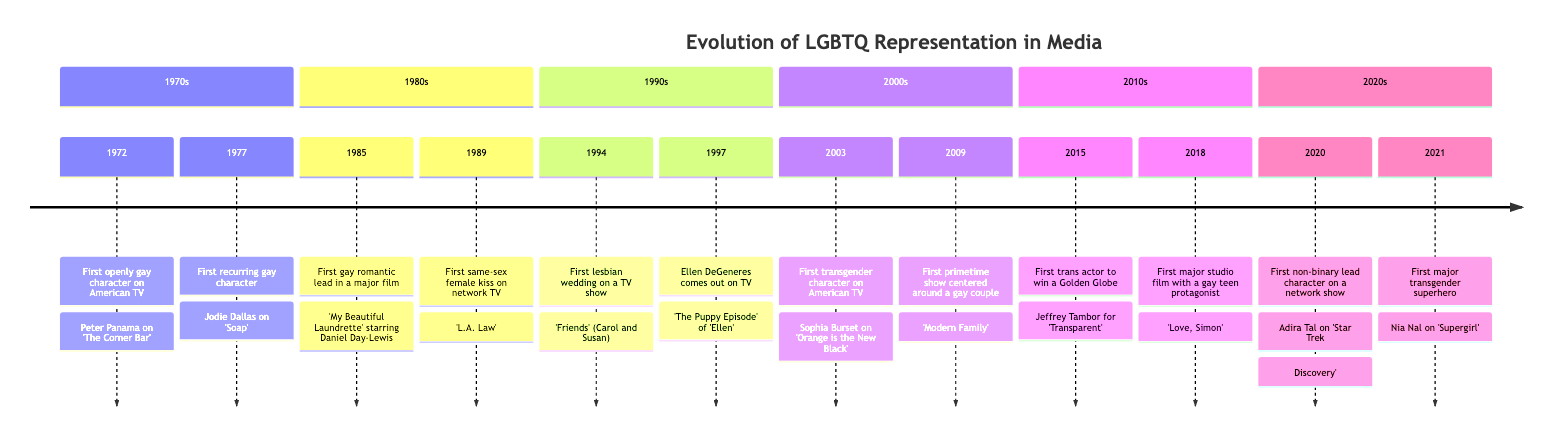What was the first openly gay character on American TV? The first openly gay character on American TV, as indicated in the diagram, is Peter Panama from 'The Corner Bar' in 1972.
Answer: Peter Panama What year did Ellen DeGeneres come out on TV? According to the timeline, Ellen DeGeneres came out on TV in 1997 during 'The Puppy Episode' of 'Ellen'.
Answer: 1997 How many key milestones are listed for the 2000s? The timeline shows two key milestones for the 2000s: the first transgender character in 2003 and the first primetime show centered around a gay couple in 2009, totaling two milestones.
Answer: 2 Which decade saw the first same-sex female kiss on network TV? The first same-sex female kiss on network TV occurred in 1989 on 'L.A. Law', so this milestone belongs to the 1980s.
Answer: 1980s What is significant about the first major studio film in 2018? The significant aspect of the film 'Love, Simon' in 2018 is that it features a gay teen protagonist, making it notable in LGBTQ representation.
Answer: gay teen protagonist What milestones represent trans representation in the 2010s? The milestones related to trans representation in the 2010s include the first trans actor to win a Golden Globe in 2015 and the first major transgender superhero in 2021. These events highlight significant progress in trans representation.
Answer: 2015, 2021 In what year was the first lesbian wedding on a TV show? The diagram specifies that the first lesbian wedding on a TV show occurred in 1994 on 'Friends' (Carol and Susan).
Answer: 1994 Identify the first transgender character on American TV. The first transgender character on American TV is Sophia Burset from 'Orange is the New Black', as shown in the timeline, which highlights the character's introduction in 2003.
Answer: Sophia Burset 